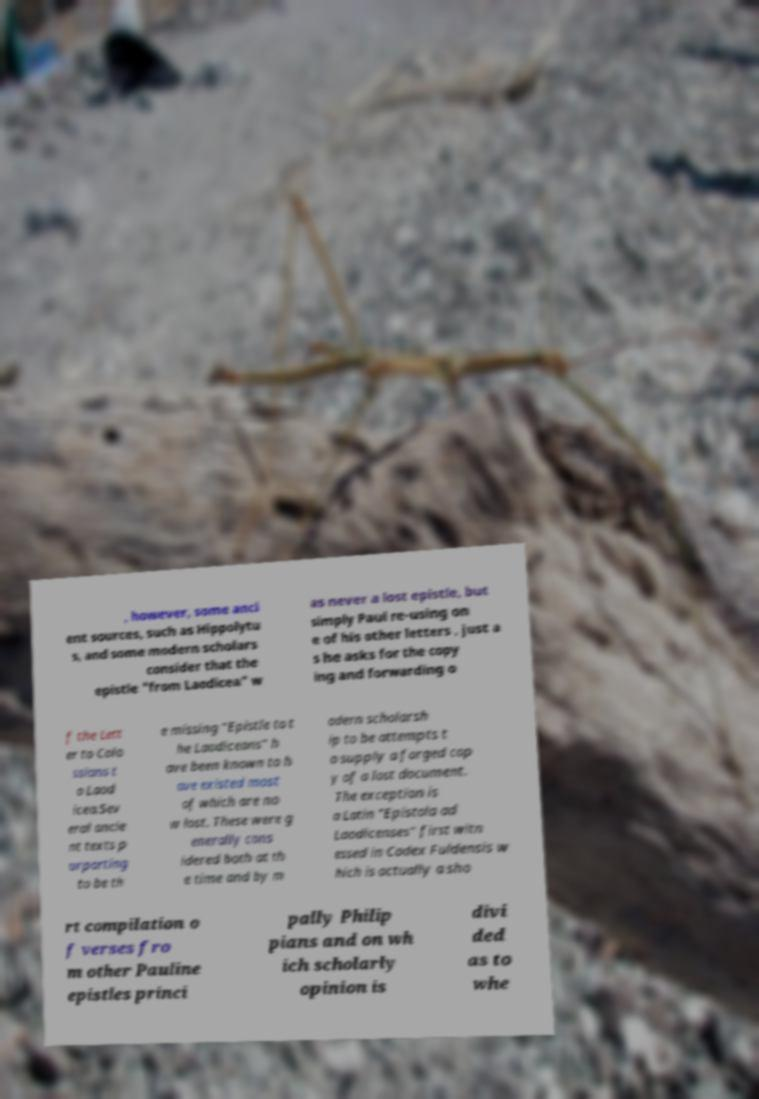Please read and relay the text visible in this image. What does it say? , however, some anci ent sources, such as Hippolytu s, and some modern scholars consider that the epistle "from Laodicea" w as never a lost epistle, but simply Paul re-using on e of his other letters , just a s he asks for the copy ing and forwarding o f the Lett er to Colo ssians t o Laod icea.Sev eral ancie nt texts p urporting to be th e missing "Epistle to t he Laodiceans" h ave been known to h ave existed most of which are no w lost. These were g enerally cons idered both at th e time and by m odern scholarsh ip to be attempts t o supply a forged cop y of a lost document. The exception is a Latin "Epistola ad Laodicenses" first witn essed in Codex Fuldensis w hich is actually a sho rt compilation o f verses fro m other Pauline epistles princi pally Philip pians and on wh ich scholarly opinion is divi ded as to whe 